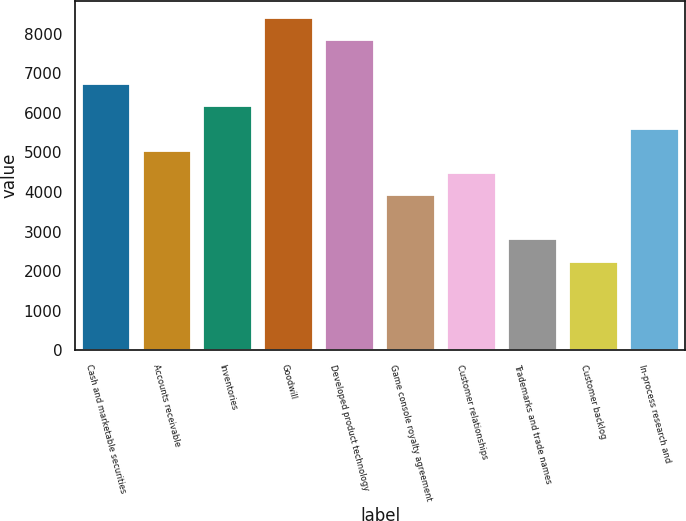Convert chart. <chart><loc_0><loc_0><loc_500><loc_500><bar_chart><fcel>Cash and marketable securities<fcel>Accounts receivable<fcel>Inventories<fcel>Goodwill<fcel>Developed product technology<fcel>Game console royalty agreement<fcel>Customer relationships<fcel>Trademarks and trade names<fcel>Customer backlog<fcel>In-process research and<nl><fcel>6724.4<fcel>5043.8<fcel>6164.2<fcel>8405<fcel>7844.8<fcel>3923.4<fcel>4483.6<fcel>2803<fcel>2242.8<fcel>5604<nl></chart> 